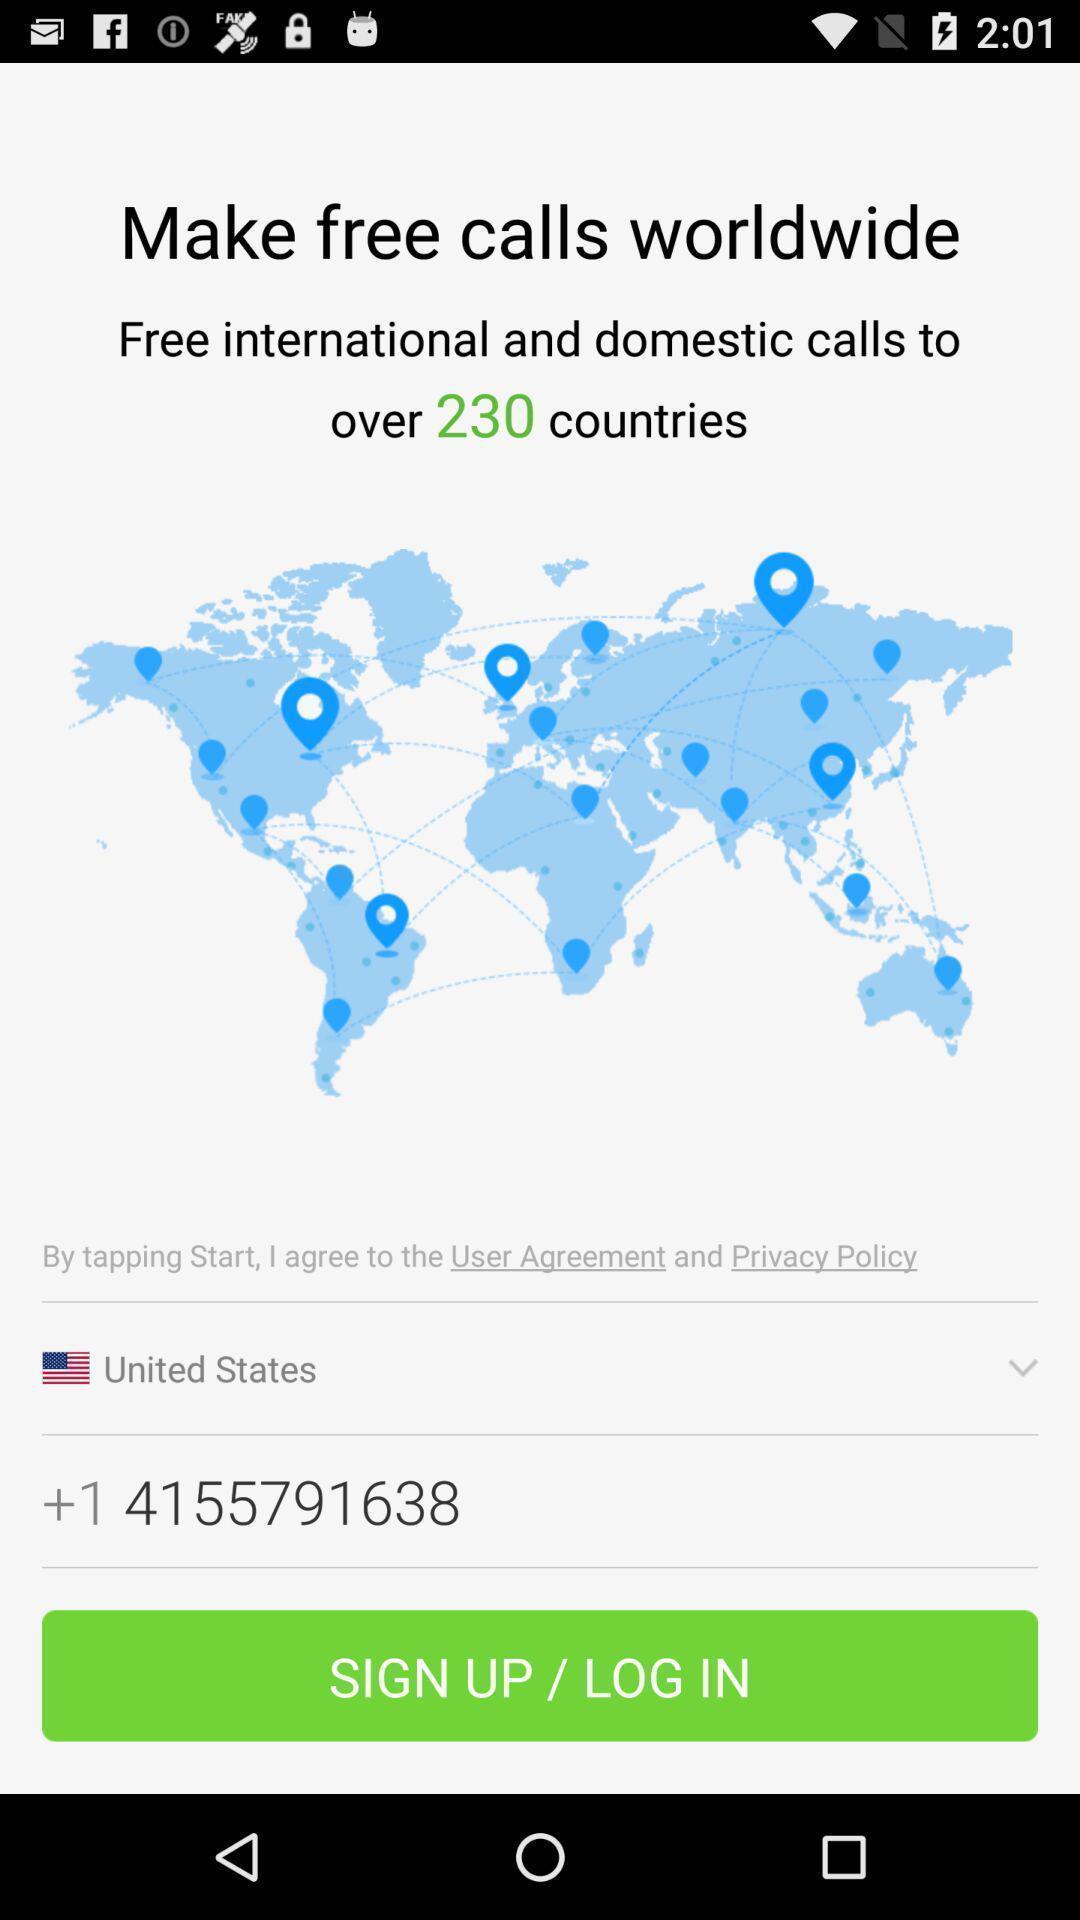Describe the key features of this screenshot. Welcome to the login page. 